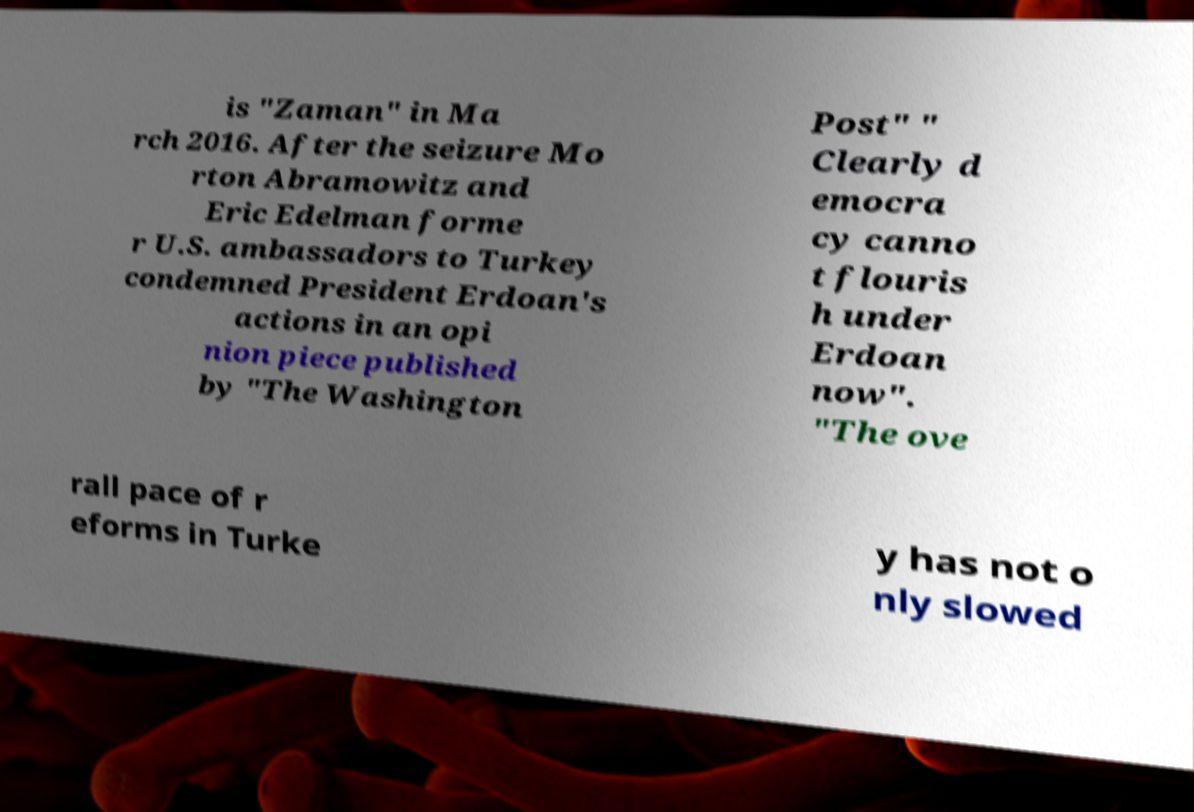Please identify and transcribe the text found in this image. is "Zaman" in Ma rch 2016. After the seizure Mo rton Abramowitz and Eric Edelman forme r U.S. ambassadors to Turkey condemned President Erdoan's actions in an opi nion piece published by "The Washington Post" " Clearly d emocra cy canno t flouris h under Erdoan now". "The ove rall pace of r eforms in Turke y has not o nly slowed 